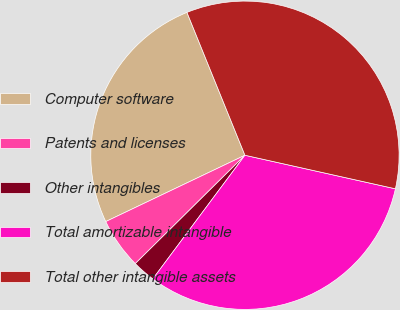Convert chart to OTSL. <chart><loc_0><loc_0><loc_500><loc_500><pie_chart><fcel>Computer software<fcel>Patents and licenses<fcel>Other intangibles<fcel>Total amortizable intangible<fcel>Total other intangible assets<nl><fcel>25.94%<fcel>5.33%<fcel>2.4%<fcel>31.7%<fcel>34.63%<nl></chart> 